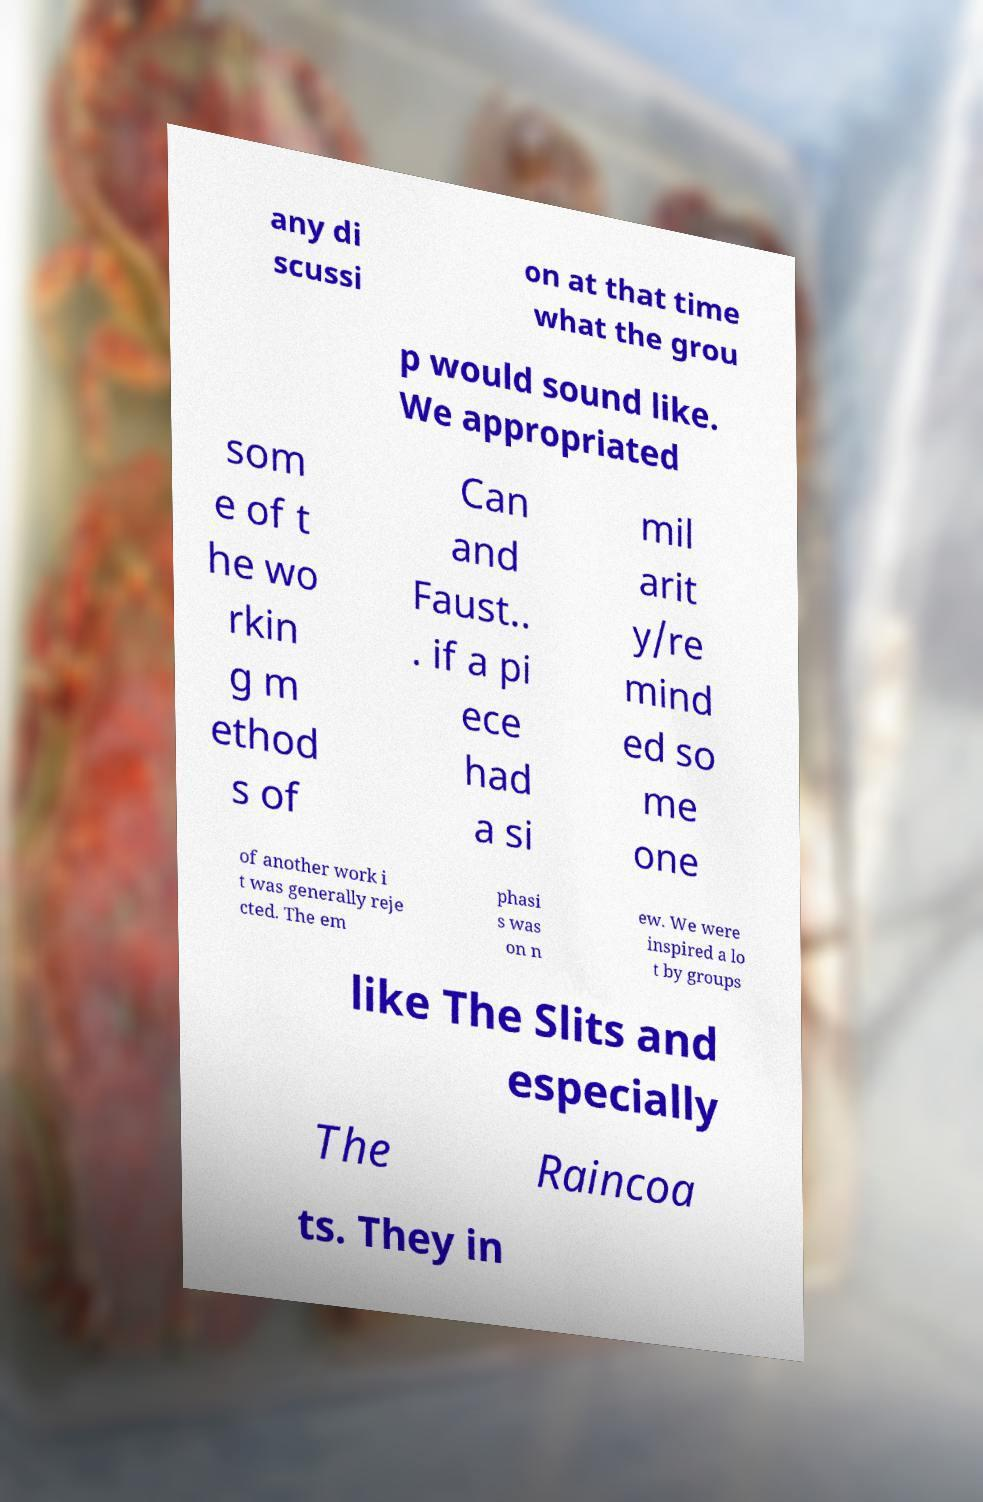Can you read and provide the text displayed in the image?This photo seems to have some interesting text. Can you extract and type it out for me? any di scussi on at that time what the grou p would sound like. We appropriated som e of t he wo rkin g m ethod s of Can and Faust.. . if a pi ece had a si mil arit y/re mind ed so me one of another work i t was generally reje cted. The em phasi s was on n ew. We were inspired a lo t by groups like The Slits and especially The Raincoa ts. They in 